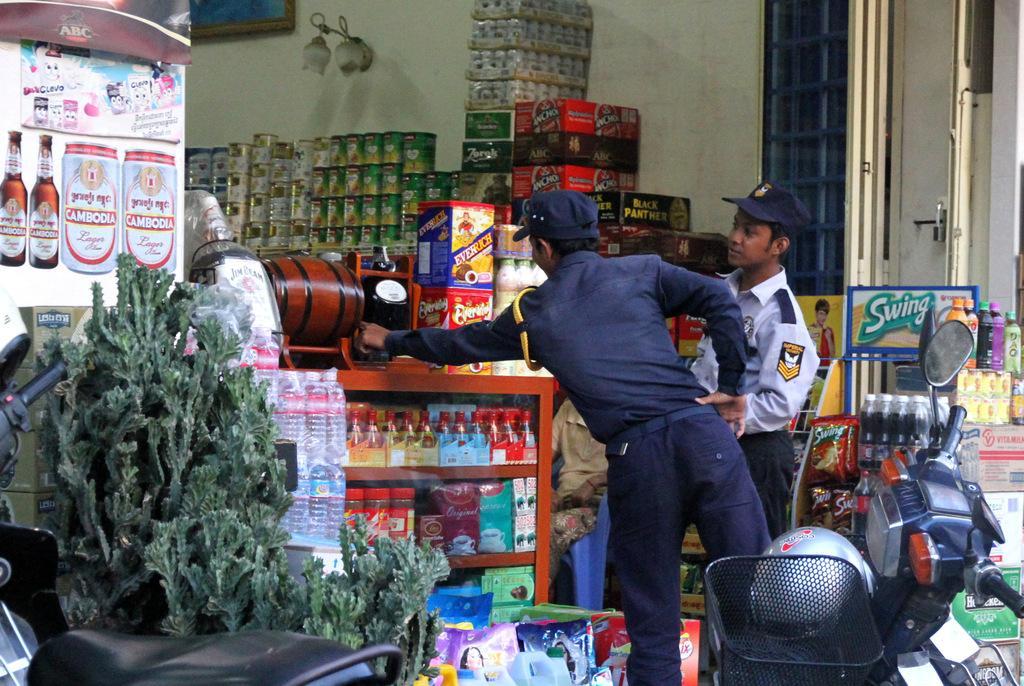Describe this image in one or two sentences. In the picture I can see two persons are standing. These people are wearing hats and uniforms. Here I can see a vehicle, plants, bottles, boxes, lights on the wall and some other objects. 